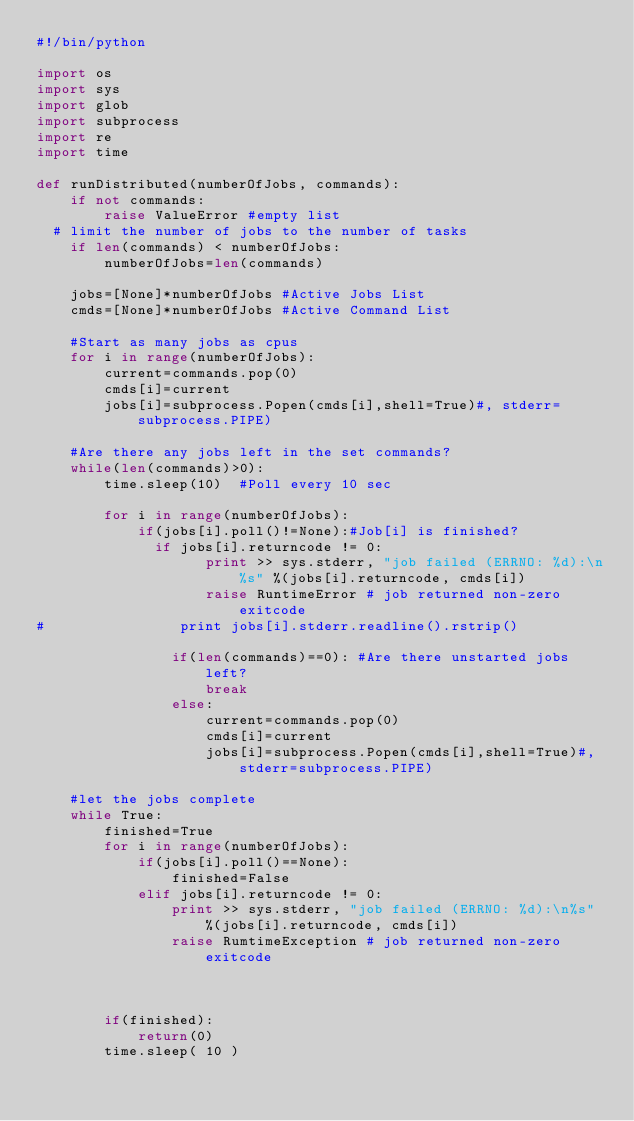<code> <loc_0><loc_0><loc_500><loc_500><_Python_>#!/bin/python

import os
import sys
import glob
import subprocess
import re
import time

def runDistributed(numberOfJobs, commands):
    if not commands:
        raise ValueError #empty list
	# limit the number of jobs to the number of tasks
    if len(commands) < numberOfJobs:
        numberOfJobs=len(commands)

    jobs=[None]*numberOfJobs #Active Jobs List
    cmds=[None]*numberOfJobs #Active Command List
    
    #Start as many jobs as cpus
    for i in range(numberOfJobs):
        current=commands.pop(0)
        cmds[i]=current
        jobs[i]=subprocess.Popen(cmds[i],shell=True)#, stderr=subprocess.PIPE)

    #Are there any jobs left in the set commands?
    while(len(commands)>0):
        time.sleep(10)  #Poll every 10 sec

        for i in range(numberOfJobs):
            if(jobs[i].poll()!=None):#Job[i] is finished? 
            	if jobs[i].returncode != 0:
                    print >> sys.stderr, "job failed (ERRNO: %d):\n%s" %(jobs[i].returncode, cmds[i])
                    raise RuntimeError # job returned non-zero exitcode
#                print jobs[i].stderr.readline().rstrip() 
                
                if(len(commands)==0): #Are there unstarted jobs left?
                    break
                else:
                    current=commands.pop(0)
                    cmds[i]=current
                    jobs[i]=subprocess.Popen(cmds[i],shell=True)#,stderr=subprocess.PIPE)

    #let the jobs complete
    while True:
        finished=True
        for i in range(numberOfJobs):
            if(jobs[i].poll()==None):
                finished=False
            elif jobs[i].returncode != 0:
                print >> sys.stderr, "job failed (ERRNO: %d):\n%s" %(jobs[i].returncode, cmds[i])
                raise RumtimeException # job returned non-zero exitcode
            
				

        if(finished):
            return(0)
        time.sleep( 10 )
	
</code> 